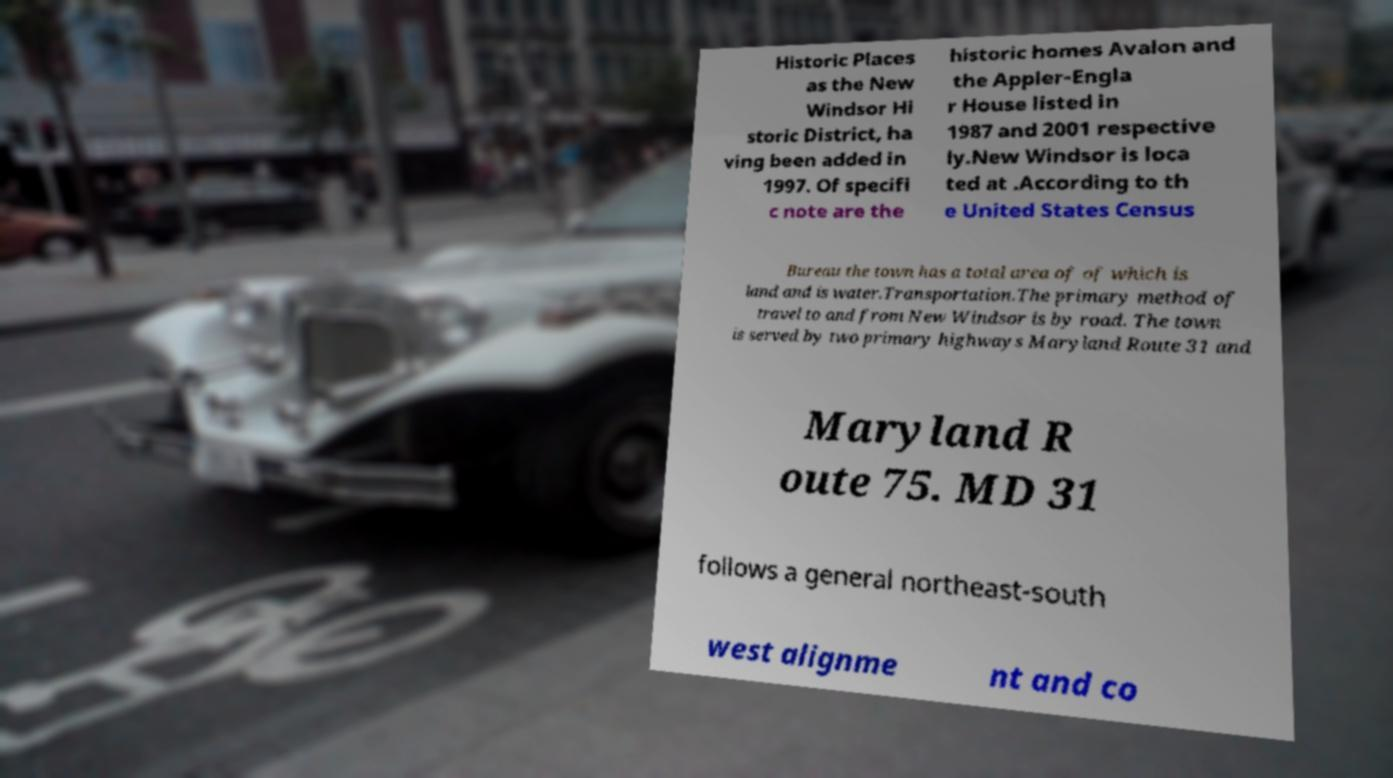Could you extract and type out the text from this image? Historic Places as the New Windsor Hi storic District, ha ving been added in 1997. Of specifi c note are the historic homes Avalon and the Appler-Engla r House listed in 1987 and 2001 respective ly.New Windsor is loca ted at .According to th e United States Census Bureau the town has a total area of of which is land and is water.Transportation.The primary method of travel to and from New Windsor is by road. The town is served by two primary highways Maryland Route 31 and Maryland R oute 75. MD 31 follows a general northeast-south west alignme nt and co 